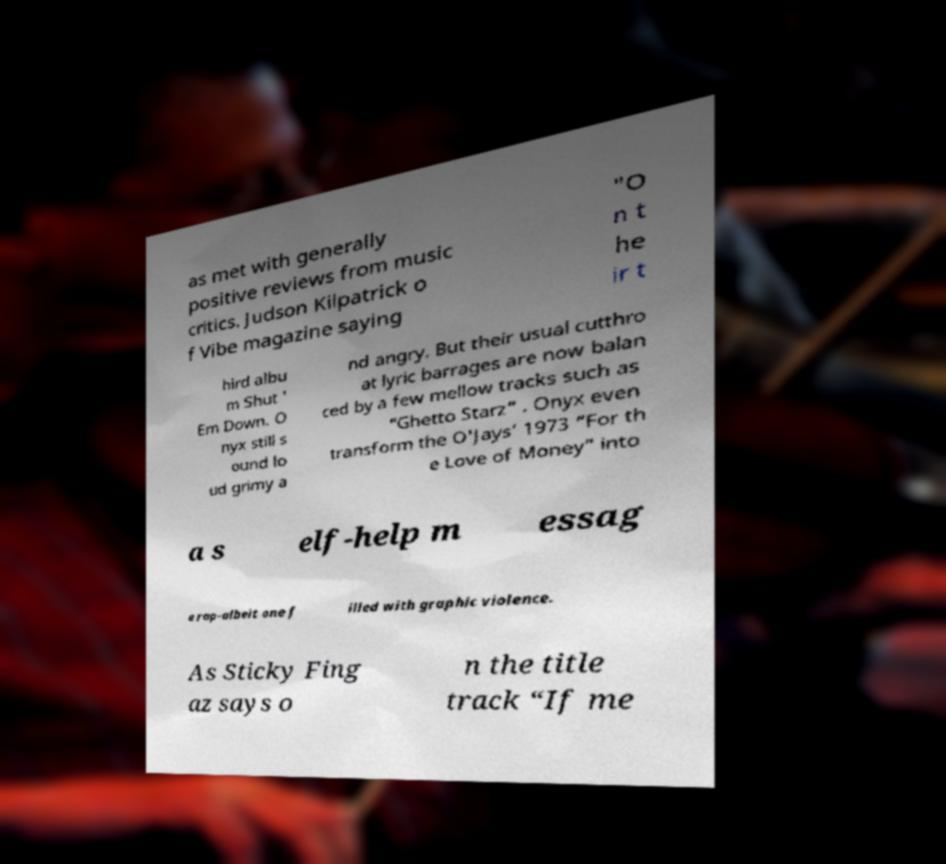Could you assist in decoding the text presented in this image and type it out clearly? as met with generally positive reviews from music critics. Judson Kilpatrick o f Vibe magazine saying "O n t he ir t hird albu m Shut ' Em Down. O nyx still s ound lo ud grimy a nd angry. But their usual cutthro at lyric barrages are now balan ced by a few mellow tracks such as “Ghetto Starz” . Onyx even transform the O'Jays’ 1973 “For th e Love of Money” into a s elf-help m essag e rap-albeit one f illed with graphic violence. As Sticky Fing az says o n the title track “If me 